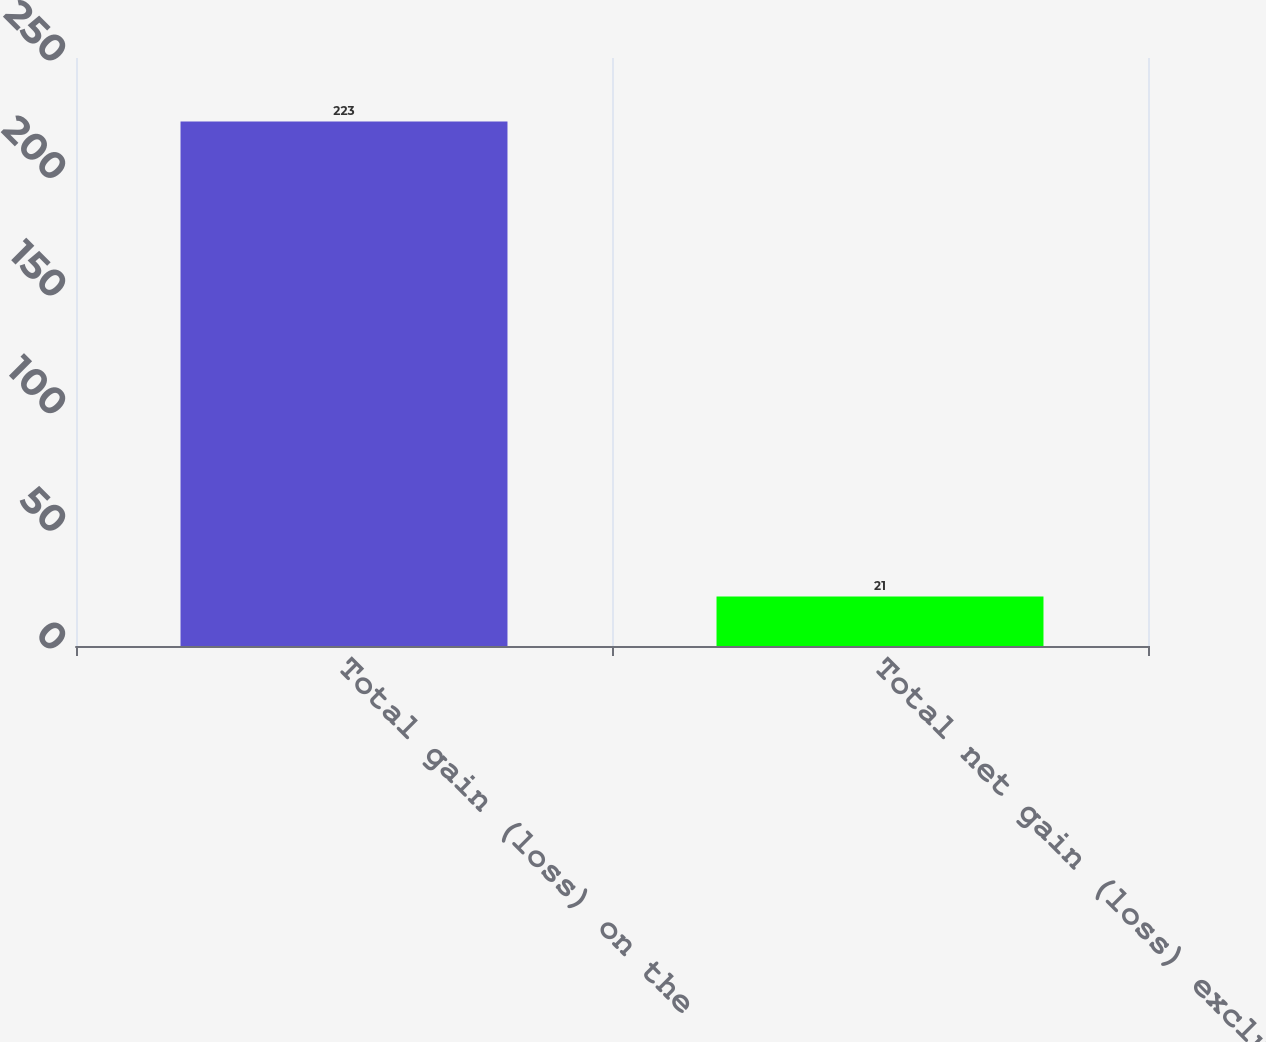Convert chart. <chart><loc_0><loc_0><loc_500><loc_500><bar_chart><fcel>Total gain (loss) on the<fcel>Total net gain (loss) excluded<nl><fcel>223<fcel>21<nl></chart> 